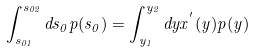<formula> <loc_0><loc_0><loc_500><loc_500>\int _ { s _ { 0 1 } } ^ { s _ { 0 2 } } d s _ { 0 } p ( s _ { 0 } ) = \int _ { y _ { 1 } } ^ { y _ { 2 } } d y x ^ { ^ { \prime } } ( y ) p ( y )</formula> 